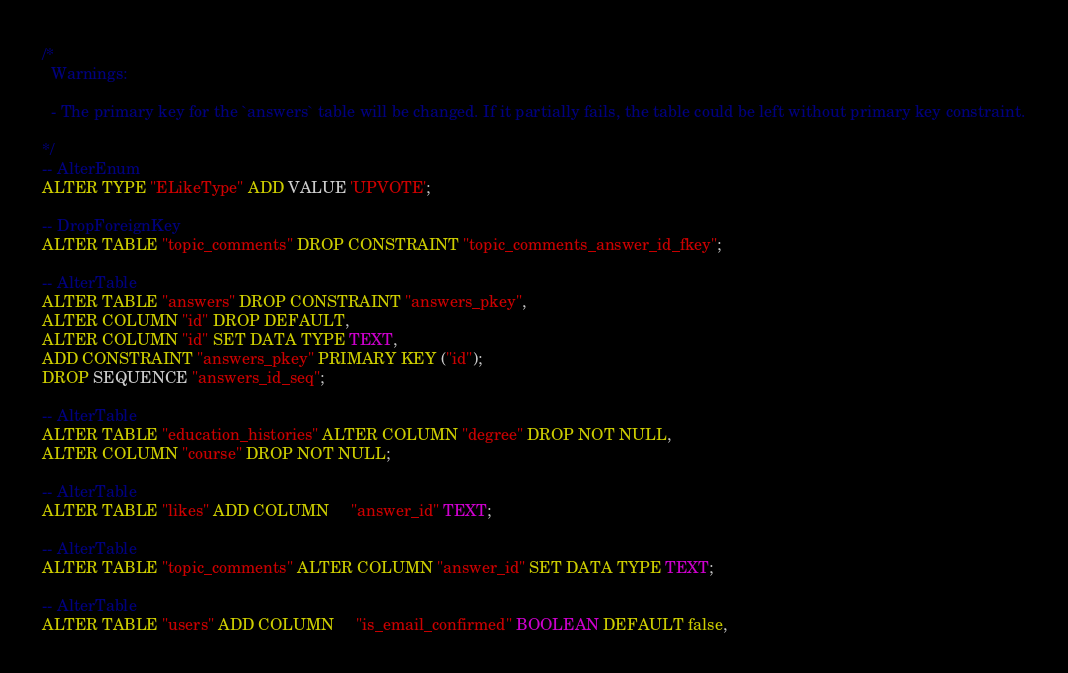Convert code to text. <code><loc_0><loc_0><loc_500><loc_500><_SQL_>/*
  Warnings:

  - The primary key for the `answers` table will be changed. If it partially fails, the table could be left without primary key constraint.

*/
-- AlterEnum
ALTER TYPE "ELikeType" ADD VALUE 'UPVOTE';

-- DropForeignKey
ALTER TABLE "topic_comments" DROP CONSTRAINT "topic_comments_answer_id_fkey";

-- AlterTable
ALTER TABLE "answers" DROP CONSTRAINT "answers_pkey",
ALTER COLUMN "id" DROP DEFAULT,
ALTER COLUMN "id" SET DATA TYPE TEXT,
ADD CONSTRAINT "answers_pkey" PRIMARY KEY ("id");
DROP SEQUENCE "answers_id_seq";

-- AlterTable
ALTER TABLE "education_histories" ALTER COLUMN "degree" DROP NOT NULL,
ALTER COLUMN "course" DROP NOT NULL;

-- AlterTable
ALTER TABLE "likes" ADD COLUMN     "answer_id" TEXT;

-- AlterTable
ALTER TABLE "topic_comments" ALTER COLUMN "answer_id" SET DATA TYPE TEXT;

-- AlterTable
ALTER TABLE "users" ADD COLUMN     "is_email_confirmed" BOOLEAN DEFAULT false,</code> 